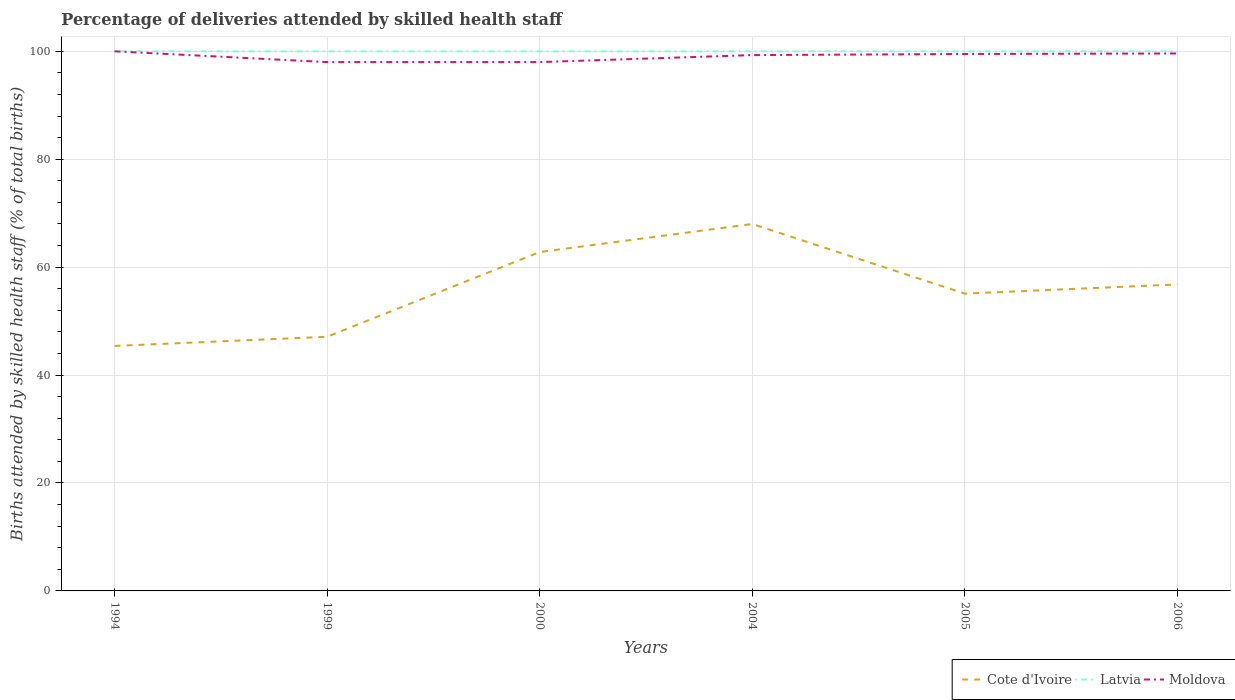How many different coloured lines are there?
Offer a terse response. 3. Does the line corresponding to Moldova intersect with the line corresponding to Cote d'Ivoire?
Your answer should be very brief. No. Across all years, what is the maximum percentage of births attended by skilled health staff in Latvia?
Your response must be concise. 100. In which year was the percentage of births attended by skilled health staff in Moldova maximum?
Your answer should be very brief. 1999. What is the total percentage of births attended by skilled health staff in Moldova in the graph?
Give a very brief answer. -1.6. How many years are there in the graph?
Your answer should be very brief. 6. Are the values on the major ticks of Y-axis written in scientific E-notation?
Your response must be concise. No. Does the graph contain grids?
Your answer should be compact. Yes. How many legend labels are there?
Ensure brevity in your answer.  3. How are the legend labels stacked?
Ensure brevity in your answer.  Horizontal. What is the title of the graph?
Keep it short and to the point. Percentage of deliveries attended by skilled health staff. Does "Ethiopia" appear as one of the legend labels in the graph?
Ensure brevity in your answer.  No. What is the label or title of the X-axis?
Your answer should be compact. Years. What is the label or title of the Y-axis?
Give a very brief answer. Births attended by skilled health staff (% of total births). What is the Births attended by skilled health staff (% of total births) of Cote d'Ivoire in 1994?
Your answer should be very brief. 45.4. What is the Births attended by skilled health staff (% of total births) of Latvia in 1994?
Keep it short and to the point. 100. What is the Births attended by skilled health staff (% of total births) of Cote d'Ivoire in 1999?
Your answer should be compact. 47.1. What is the Births attended by skilled health staff (% of total births) in Cote d'Ivoire in 2000?
Keep it short and to the point. 62.8. What is the Births attended by skilled health staff (% of total births) of Latvia in 2000?
Make the answer very short. 100. What is the Births attended by skilled health staff (% of total births) in Moldova in 2000?
Offer a very short reply. 98. What is the Births attended by skilled health staff (% of total births) in Latvia in 2004?
Provide a short and direct response. 100. What is the Births attended by skilled health staff (% of total births) in Moldova in 2004?
Provide a succinct answer. 99.3. What is the Births attended by skilled health staff (% of total births) in Cote d'Ivoire in 2005?
Offer a terse response. 55.1. What is the Births attended by skilled health staff (% of total births) in Moldova in 2005?
Offer a very short reply. 99.5. What is the Births attended by skilled health staff (% of total births) of Cote d'Ivoire in 2006?
Your response must be concise. 56.8. What is the Births attended by skilled health staff (% of total births) of Latvia in 2006?
Ensure brevity in your answer.  100. What is the Births attended by skilled health staff (% of total births) of Moldova in 2006?
Your answer should be very brief. 99.6. Across all years, what is the minimum Births attended by skilled health staff (% of total births) of Cote d'Ivoire?
Give a very brief answer. 45.4. Across all years, what is the minimum Births attended by skilled health staff (% of total births) in Moldova?
Provide a succinct answer. 98. What is the total Births attended by skilled health staff (% of total births) in Cote d'Ivoire in the graph?
Give a very brief answer. 335.2. What is the total Births attended by skilled health staff (% of total births) in Latvia in the graph?
Provide a short and direct response. 600. What is the total Births attended by skilled health staff (% of total births) of Moldova in the graph?
Provide a short and direct response. 594.4. What is the difference between the Births attended by skilled health staff (% of total births) of Cote d'Ivoire in 1994 and that in 1999?
Offer a very short reply. -1.7. What is the difference between the Births attended by skilled health staff (% of total births) of Latvia in 1994 and that in 1999?
Give a very brief answer. 0. What is the difference between the Births attended by skilled health staff (% of total births) in Cote d'Ivoire in 1994 and that in 2000?
Offer a terse response. -17.4. What is the difference between the Births attended by skilled health staff (% of total births) in Latvia in 1994 and that in 2000?
Provide a succinct answer. 0. What is the difference between the Births attended by skilled health staff (% of total births) of Moldova in 1994 and that in 2000?
Offer a very short reply. 2. What is the difference between the Births attended by skilled health staff (% of total births) in Cote d'Ivoire in 1994 and that in 2004?
Your answer should be very brief. -22.6. What is the difference between the Births attended by skilled health staff (% of total births) in Latvia in 1994 and that in 2004?
Provide a short and direct response. 0. What is the difference between the Births attended by skilled health staff (% of total births) of Moldova in 1994 and that in 2004?
Your answer should be very brief. 0.7. What is the difference between the Births attended by skilled health staff (% of total births) of Moldova in 1994 and that in 2005?
Make the answer very short. 0.5. What is the difference between the Births attended by skilled health staff (% of total births) of Latvia in 1994 and that in 2006?
Your answer should be compact. 0. What is the difference between the Births attended by skilled health staff (% of total births) in Cote d'Ivoire in 1999 and that in 2000?
Provide a short and direct response. -15.7. What is the difference between the Births attended by skilled health staff (% of total births) in Cote d'Ivoire in 1999 and that in 2004?
Provide a succinct answer. -20.9. What is the difference between the Births attended by skilled health staff (% of total births) in Moldova in 1999 and that in 2004?
Offer a terse response. -1.3. What is the difference between the Births attended by skilled health staff (% of total births) of Cote d'Ivoire in 1999 and that in 2005?
Offer a very short reply. -8. What is the difference between the Births attended by skilled health staff (% of total births) of Cote d'Ivoire in 1999 and that in 2006?
Offer a very short reply. -9.7. What is the difference between the Births attended by skilled health staff (% of total births) in Cote d'Ivoire in 2000 and that in 2004?
Your response must be concise. -5.2. What is the difference between the Births attended by skilled health staff (% of total births) of Cote d'Ivoire in 2000 and that in 2005?
Make the answer very short. 7.7. What is the difference between the Births attended by skilled health staff (% of total births) of Latvia in 2000 and that in 2005?
Provide a short and direct response. 0. What is the difference between the Births attended by skilled health staff (% of total births) in Cote d'Ivoire in 2000 and that in 2006?
Make the answer very short. 6. What is the difference between the Births attended by skilled health staff (% of total births) in Latvia in 2000 and that in 2006?
Your response must be concise. 0. What is the difference between the Births attended by skilled health staff (% of total births) of Moldova in 2000 and that in 2006?
Offer a terse response. -1.6. What is the difference between the Births attended by skilled health staff (% of total births) in Cote d'Ivoire in 2004 and that in 2005?
Your answer should be very brief. 12.9. What is the difference between the Births attended by skilled health staff (% of total births) in Latvia in 2004 and that in 2005?
Your answer should be very brief. 0. What is the difference between the Births attended by skilled health staff (% of total births) of Cote d'Ivoire in 2004 and that in 2006?
Offer a terse response. 11.2. What is the difference between the Births attended by skilled health staff (% of total births) in Cote d'Ivoire in 2005 and that in 2006?
Make the answer very short. -1.7. What is the difference between the Births attended by skilled health staff (% of total births) of Latvia in 2005 and that in 2006?
Provide a succinct answer. 0. What is the difference between the Births attended by skilled health staff (% of total births) of Cote d'Ivoire in 1994 and the Births attended by skilled health staff (% of total births) of Latvia in 1999?
Provide a succinct answer. -54.6. What is the difference between the Births attended by skilled health staff (% of total births) in Cote d'Ivoire in 1994 and the Births attended by skilled health staff (% of total births) in Moldova in 1999?
Provide a short and direct response. -52.6. What is the difference between the Births attended by skilled health staff (% of total births) of Cote d'Ivoire in 1994 and the Births attended by skilled health staff (% of total births) of Latvia in 2000?
Your response must be concise. -54.6. What is the difference between the Births attended by skilled health staff (% of total births) of Cote d'Ivoire in 1994 and the Births attended by skilled health staff (% of total births) of Moldova in 2000?
Ensure brevity in your answer.  -52.6. What is the difference between the Births attended by skilled health staff (% of total births) of Latvia in 1994 and the Births attended by skilled health staff (% of total births) of Moldova in 2000?
Ensure brevity in your answer.  2. What is the difference between the Births attended by skilled health staff (% of total births) in Cote d'Ivoire in 1994 and the Births attended by skilled health staff (% of total births) in Latvia in 2004?
Offer a very short reply. -54.6. What is the difference between the Births attended by skilled health staff (% of total births) of Cote d'Ivoire in 1994 and the Births attended by skilled health staff (% of total births) of Moldova in 2004?
Your answer should be very brief. -53.9. What is the difference between the Births attended by skilled health staff (% of total births) in Latvia in 1994 and the Births attended by skilled health staff (% of total births) in Moldova in 2004?
Make the answer very short. 0.7. What is the difference between the Births attended by skilled health staff (% of total births) in Cote d'Ivoire in 1994 and the Births attended by skilled health staff (% of total births) in Latvia in 2005?
Your response must be concise. -54.6. What is the difference between the Births attended by skilled health staff (% of total births) of Cote d'Ivoire in 1994 and the Births attended by skilled health staff (% of total births) of Moldova in 2005?
Offer a very short reply. -54.1. What is the difference between the Births attended by skilled health staff (% of total births) of Latvia in 1994 and the Births attended by skilled health staff (% of total births) of Moldova in 2005?
Offer a terse response. 0.5. What is the difference between the Births attended by skilled health staff (% of total births) of Cote d'Ivoire in 1994 and the Births attended by skilled health staff (% of total births) of Latvia in 2006?
Give a very brief answer. -54.6. What is the difference between the Births attended by skilled health staff (% of total births) in Cote d'Ivoire in 1994 and the Births attended by skilled health staff (% of total births) in Moldova in 2006?
Offer a terse response. -54.2. What is the difference between the Births attended by skilled health staff (% of total births) in Latvia in 1994 and the Births attended by skilled health staff (% of total births) in Moldova in 2006?
Your answer should be compact. 0.4. What is the difference between the Births attended by skilled health staff (% of total births) of Cote d'Ivoire in 1999 and the Births attended by skilled health staff (% of total births) of Latvia in 2000?
Your response must be concise. -52.9. What is the difference between the Births attended by skilled health staff (% of total births) of Cote d'Ivoire in 1999 and the Births attended by skilled health staff (% of total births) of Moldova in 2000?
Provide a short and direct response. -50.9. What is the difference between the Births attended by skilled health staff (% of total births) of Latvia in 1999 and the Births attended by skilled health staff (% of total births) of Moldova in 2000?
Provide a short and direct response. 2. What is the difference between the Births attended by skilled health staff (% of total births) in Cote d'Ivoire in 1999 and the Births attended by skilled health staff (% of total births) in Latvia in 2004?
Make the answer very short. -52.9. What is the difference between the Births attended by skilled health staff (% of total births) in Cote d'Ivoire in 1999 and the Births attended by skilled health staff (% of total births) in Moldova in 2004?
Keep it short and to the point. -52.2. What is the difference between the Births attended by skilled health staff (% of total births) of Latvia in 1999 and the Births attended by skilled health staff (% of total births) of Moldova in 2004?
Provide a short and direct response. 0.7. What is the difference between the Births attended by skilled health staff (% of total births) of Cote d'Ivoire in 1999 and the Births attended by skilled health staff (% of total births) of Latvia in 2005?
Your answer should be compact. -52.9. What is the difference between the Births attended by skilled health staff (% of total births) in Cote d'Ivoire in 1999 and the Births attended by skilled health staff (% of total births) in Moldova in 2005?
Your response must be concise. -52.4. What is the difference between the Births attended by skilled health staff (% of total births) of Cote d'Ivoire in 1999 and the Births attended by skilled health staff (% of total births) of Latvia in 2006?
Keep it short and to the point. -52.9. What is the difference between the Births attended by skilled health staff (% of total births) in Cote d'Ivoire in 1999 and the Births attended by skilled health staff (% of total births) in Moldova in 2006?
Provide a succinct answer. -52.5. What is the difference between the Births attended by skilled health staff (% of total births) of Cote d'Ivoire in 2000 and the Births attended by skilled health staff (% of total births) of Latvia in 2004?
Provide a succinct answer. -37.2. What is the difference between the Births attended by skilled health staff (% of total births) in Cote d'Ivoire in 2000 and the Births attended by skilled health staff (% of total births) in Moldova in 2004?
Make the answer very short. -36.5. What is the difference between the Births attended by skilled health staff (% of total births) of Cote d'Ivoire in 2000 and the Births attended by skilled health staff (% of total births) of Latvia in 2005?
Offer a terse response. -37.2. What is the difference between the Births attended by skilled health staff (% of total births) in Cote d'Ivoire in 2000 and the Births attended by skilled health staff (% of total births) in Moldova in 2005?
Ensure brevity in your answer.  -36.7. What is the difference between the Births attended by skilled health staff (% of total births) of Cote d'Ivoire in 2000 and the Births attended by skilled health staff (% of total births) of Latvia in 2006?
Provide a succinct answer. -37.2. What is the difference between the Births attended by skilled health staff (% of total births) of Cote d'Ivoire in 2000 and the Births attended by skilled health staff (% of total births) of Moldova in 2006?
Give a very brief answer. -36.8. What is the difference between the Births attended by skilled health staff (% of total births) in Cote d'Ivoire in 2004 and the Births attended by skilled health staff (% of total births) in Latvia in 2005?
Your response must be concise. -32. What is the difference between the Births attended by skilled health staff (% of total births) in Cote d'Ivoire in 2004 and the Births attended by skilled health staff (% of total births) in Moldova in 2005?
Give a very brief answer. -31.5. What is the difference between the Births attended by skilled health staff (% of total births) in Latvia in 2004 and the Births attended by skilled health staff (% of total births) in Moldova in 2005?
Your response must be concise. 0.5. What is the difference between the Births attended by skilled health staff (% of total births) in Cote d'Ivoire in 2004 and the Births attended by skilled health staff (% of total births) in Latvia in 2006?
Ensure brevity in your answer.  -32. What is the difference between the Births attended by skilled health staff (% of total births) of Cote d'Ivoire in 2004 and the Births attended by skilled health staff (% of total births) of Moldova in 2006?
Your response must be concise. -31.6. What is the difference between the Births attended by skilled health staff (% of total births) of Cote d'Ivoire in 2005 and the Births attended by skilled health staff (% of total births) of Latvia in 2006?
Your answer should be very brief. -44.9. What is the difference between the Births attended by skilled health staff (% of total births) of Cote d'Ivoire in 2005 and the Births attended by skilled health staff (% of total births) of Moldova in 2006?
Offer a very short reply. -44.5. What is the difference between the Births attended by skilled health staff (% of total births) in Latvia in 2005 and the Births attended by skilled health staff (% of total births) in Moldova in 2006?
Keep it short and to the point. 0.4. What is the average Births attended by skilled health staff (% of total births) of Cote d'Ivoire per year?
Offer a very short reply. 55.87. What is the average Births attended by skilled health staff (% of total births) in Moldova per year?
Provide a short and direct response. 99.07. In the year 1994, what is the difference between the Births attended by skilled health staff (% of total births) of Cote d'Ivoire and Births attended by skilled health staff (% of total births) of Latvia?
Give a very brief answer. -54.6. In the year 1994, what is the difference between the Births attended by skilled health staff (% of total births) of Cote d'Ivoire and Births attended by skilled health staff (% of total births) of Moldova?
Make the answer very short. -54.6. In the year 1994, what is the difference between the Births attended by skilled health staff (% of total births) of Latvia and Births attended by skilled health staff (% of total births) of Moldova?
Provide a short and direct response. 0. In the year 1999, what is the difference between the Births attended by skilled health staff (% of total births) in Cote d'Ivoire and Births attended by skilled health staff (% of total births) in Latvia?
Offer a very short reply. -52.9. In the year 1999, what is the difference between the Births attended by skilled health staff (% of total births) of Cote d'Ivoire and Births attended by skilled health staff (% of total births) of Moldova?
Provide a short and direct response. -50.9. In the year 1999, what is the difference between the Births attended by skilled health staff (% of total births) in Latvia and Births attended by skilled health staff (% of total births) in Moldova?
Give a very brief answer. 2. In the year 2000, what is the difference between the Births attended by skilled health staff (% of total births) in Cote d'Ivoire and Births attended by skilled health staff (% of total births) in Latvia?
Give a very brief answer. -37.2. In the year 2000, what is the difference between the Births attended by skilled health staff (% of total births) of Cote d'Ivoire and Births attended by skilled health staff (% of total births) of Moldova?
Your answer should be compact. -35.2. In the year 2004, what is the difference between the Births attended by skilled health staff (% of total births) in Cote d'Ivoire and Births attended by skilled health staff (% of total births) in Latvia?
Give a very brief answer. -32. In the year 2004, what is the difference between the Births attended by skilled health staff (% of total births) in Cote d'Ivoire and Births attended by skilled health staff (% of total births) in Moldova?
Provide a short and direct response. -31.3. In the year 2004, what is the difference between the Births attended by skilled health staff (% of total births) in Latvia and Births attended by skilled health staff (% of total births) in Moldova?
Make the answer very short. 0.7. In the year 2005, what is the difference between the Births attended by skilled health staff (% of total births) in Cote d'Ivoire and Births attended by skilled health staff (% of total births) in Latvia?
Make the answer very short. -44.9. In the year 2005, what is the difference between the Births attended by skilled health staff (% of total births) of Cote d'Ivoire and Births attended by skilled health staff (% of total births) of Moldova?
Make the answer very short. -44.4. In the year 2005, what is the difference between the Births attended by skilled health staff (% of total births) of Latvia and Births attended by skilled health staff (% of total births) of Moldova?
Give a very brief answer. 0.5. In the year 2006, what is the difference between the Births attended by skilled health staff (% of total births) of Cote d'Ivoire and Births attended by skilled health staff (% of total births) of Latvia?
Offer a terse response. -43.2. In the year 2006, what is the difference between the Births attended by skilled health staff (% of total births) of Cote d'Ivoire and Births attended by skilled health staff (% of total births) of Moldova?
Your response must be concise. -42.8. In the year 2006, what is the difference between the Births attended by skilled health staff (% of total births) in Latvia and Births attended by skilled health staff (% of total births) in Moldova?
Provide a short and direct response. 0.4. What is the ratio of the Births attended by skilled health staff (% of total births) of Cote d'Ivoire in 1994 to that in 1999?
Keep it short and to the point. 0.96. What is the ratio of the Births attended by skilled health staff (% of total births) of Latvia in 1994 to that in 1999?
Make the answer very short. 1. What is the ratio of the Births attended by skilled health staff (% of total births) of Moldova in 1994 to that in 1999?
Keep it short and to the point. 1.02. What is the ratio of the Births attended by skilled health staff (% of total births) in Cote d'Ivoire in 1994 to that in 2000?
Make the answer very short. 0.72. What is the ratio of the Births attended by skilled health staff (% of total births) in Latvia in 1994 to that in 2000?
Make the answer very short. 1. What is the ratio of the Births attended by skilled health staff (% of total births) of Moldova in 1994 to that in 2000?
Your response must be concise. 1.02. What is the ratio of the Births attended by skilled health staff (% of total births) in Cote d'Ivoire in 1994 to that in 2004?
Provide a short and direct response. 0.67. What is the ratio of the Births attended by skilled health staff (% of total births) of Latvia in 1994 to that in 2004?
Your answer should be very brief. 1. What is the ratio of the Births attended by skilled health staff (% of total births) in Cote d'Ivoire in 1994 to that in 2005?
Ensure brevity in your answer.  0.82. What is the ratio of the Births attended by skilled health staff (% of total births) in Cote d'Ivoire in 1994 to that in 2006?
Offer a very short reply. 0.8. What is the ratio of the Births attended by skilled health staff (% of total births) of Latvia in 1994 to that in 2006?
Your response must be concise. 1. What is the ratio of the Births attended by skilled health staff (% of total births) of Cote d'Ivoire in 1999 to that in 2000?
Give a very brief answer. 0.75. What is the ratio of the Births attended by skilled health staff (% of total births) of Latvia in 1999 to that in 2000?
Your answer should be very brief. 1. What is the ratio of the Births attended by skilled health staff (% of total births) in Cote d'Ivoire in 1999 to that in 2004?
Your response must be concise. 0.69. What is the ratio of the Births attended by skilled health staff (% of total births) of Moldova in 1999 to that in 2004?
Provide a short and direct response. 0.99. What is the ratio of the Births attended by skilled health staff (% of total births) in Cote d'Ivoire in 1999 to that in 2005?
Keep it short and to the point. 0.85. What is the ratio of the Births attended by skilled health staff (% of total births) of Latvia in 1999 to that in 2005?
Offer a very short reply. 1. What is the ratio of the Births attended by skilled health staff (% of total births) in Moldova in 1999 to that in 2005?
Keep it short and to the point. 0.98. What is the ratio of the Births attended by skilled health staff (% of total births) of Cote d'Ivoire in 1999 to that in 2006?
Keep it short and to the point. 0.83. What is the ratio of the Births attended by skilled health staff (% of total births) of Moldova in 1999 to that in 2006?
Your answer should be very brief. 0.98. What is the ratio of the Births attended by skilled health staff (% of total births) in Cote d'Ivoire in 2000 to that in 2004?
Provide a short and direct response. 0.92. What is the ratio of the Births attended by skilled health staff (% of total births) of Latvia in 2000 to that in 2004?
Your answer should be very brief. 1. What is the ratio of the Births attended by skilled health staff (% of total births) of Moldova in 2000 to that in 2004?
Provide a succinct answer. 0.99. What is the ratio of the Births attended by skilled health staff (% of total births) in Cote d'Ivoire in 2000 to that in 2005?
Provide a succinct answer. 1.14. What is the ratio of the Births attended by skilled health staff (% of total births) of Latvia in 2000 to that in 2005?
Keep it short and to the point. 1. What is the ratio of the Births attended by skilled health staff (% of total births) in Moldova in 2000 to that in 2005?
Your answer should be very brief. 0.98. What is the ratio of the Births attended by skilled health staff (% of total births) in Cote d'Ivoire in 2000 to that in 2006?
Your response must be concise. 1.11. What is the ratio of the Births attended by skilled health staff (% of total births) in Moldova in 2000 to that in 2006?
Offer a very short reply. 0.98. What is the ratio of the Births attended by skilled health staff (% of total births) in Cote d'Ivoire in 2004 to that in 2005?
Keep it short and to the point. 1.23. What is the ratio of the Births attended by skilled health staff (% of total births) of Latvia in 2004 to that in 2005?
Offer a terse response. 1. What is the ratio of the Births attended by skilled health staff (% of total births) of Moldova in 2004 to that in 2005?
Provide a short and direct response. 1. What is the ratio of the Births attended by skilled health staff (% of total births) in Cote d'Ivoire in 2004 to that in 2006?
Give a very brief answer. 1.2. What is the ratio of the Births attended by skilled health staff (% of total births) in Latvia in 2004 to that in 2006?
Make the answer very short. 1. What is the ratio of the Births attended by skilled health staff (% of total births) of Moldova in 2004 to that in 2006?
Your answer should be very brief. 1. What is the ratio of the Births attended by skilled health staff (% of total births) of Cote d'Ivoire in 2005 to that in 2006?
Offer a very short reply. 0.97. What is the difference between the highest and the second highest Births attended by skilled health staff (% of total births) in Moldova?
Your answer should be very brief. 0.4. What is the difference between the highest and the lowest Births attended by skilled health staff (% of total births) of Cote d'Ivoire?
Offer a very short reply. 22.6. What is the difference between the highest and the lowest Births attended by skilled health staff (% of total births) in Latvia?
Ensure brevity in your answer.  0. What is the difference between the highest and the lowest Births attended by skilled health staff (% of total births) of Moldova?
Keep it short and to the point. 2. 